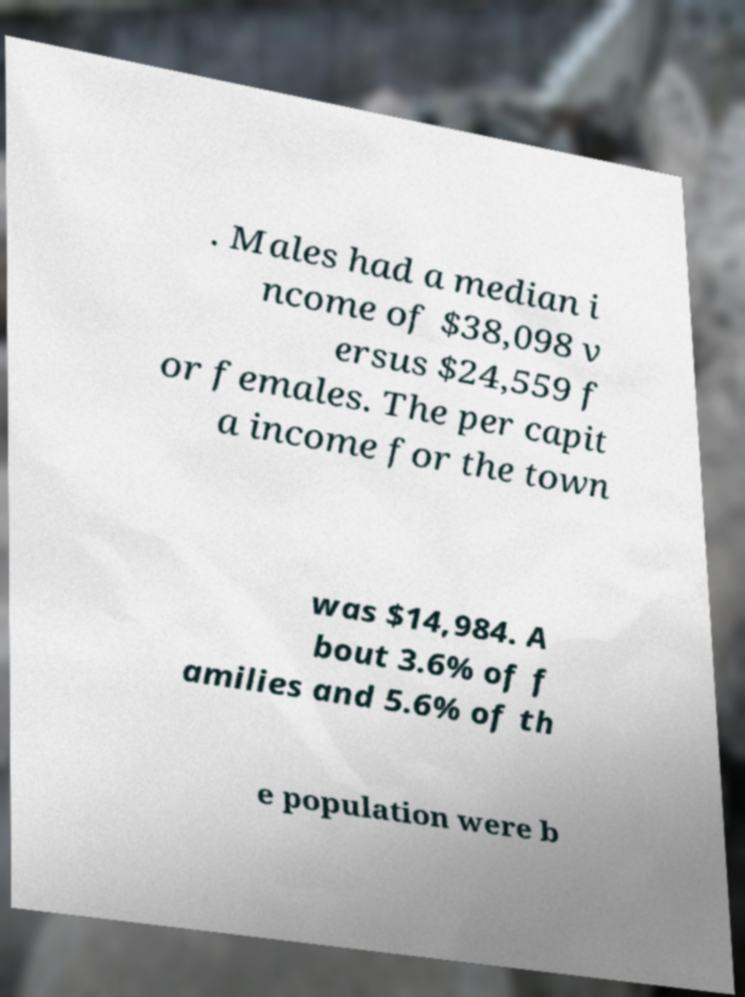I need the written content from this picture converted into text. Can you do that? . Males had a median i ncome of $38,098 v ersus $24,559 f or females. The per capit a income for the town was $14,984. A bout 3.6% of f amilies and 5.6% of th e population were b 